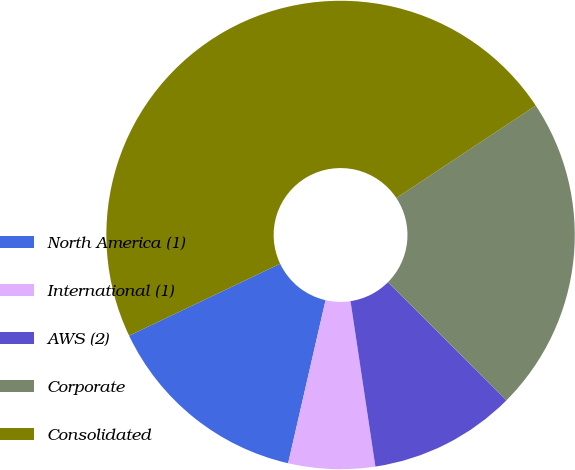Convert chart. <chart><loc_0><loc_0><loc_500><loc_500><pie_chart><fcel>North America (1)<fcel>International (1)<fcel>AWS (2)<fcel>Corporate<fcel>Consolidated<nl><fcel>14.33%<fcel>5.97%<fcel>10.15%<fcel>21.79%<fcel>47.76%<nl></chart> 